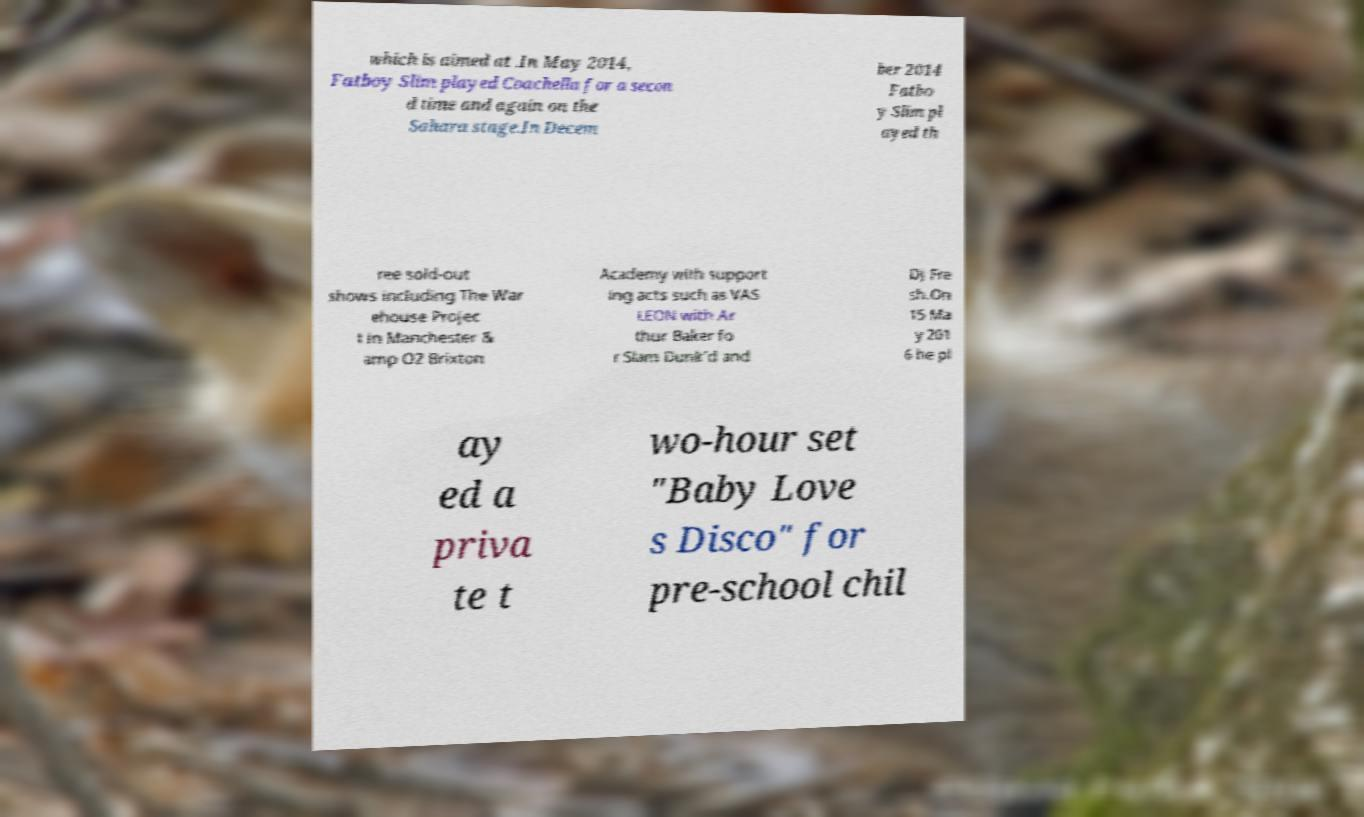Please read and relay the text visible in this image. What does it say? which is aimed at .In May 2014, Fatboy Slim played Coachella for a secon d time and again on the Sahara stage.In Decem ber 2014 Fatbo y Slim pl ayed th ree sold-out shows including The War ehouse Projec t in Manchester & amp O2 Brixton Academy with support ing acts such as VAS LEON with Ar thur Baker fo r Slam Dunk'd and DJ Fre sh.On 15 Ma y 201 6 he pl ay ed a priva te t wo-hour set "Baby Love s Disco" for pre-school chil 